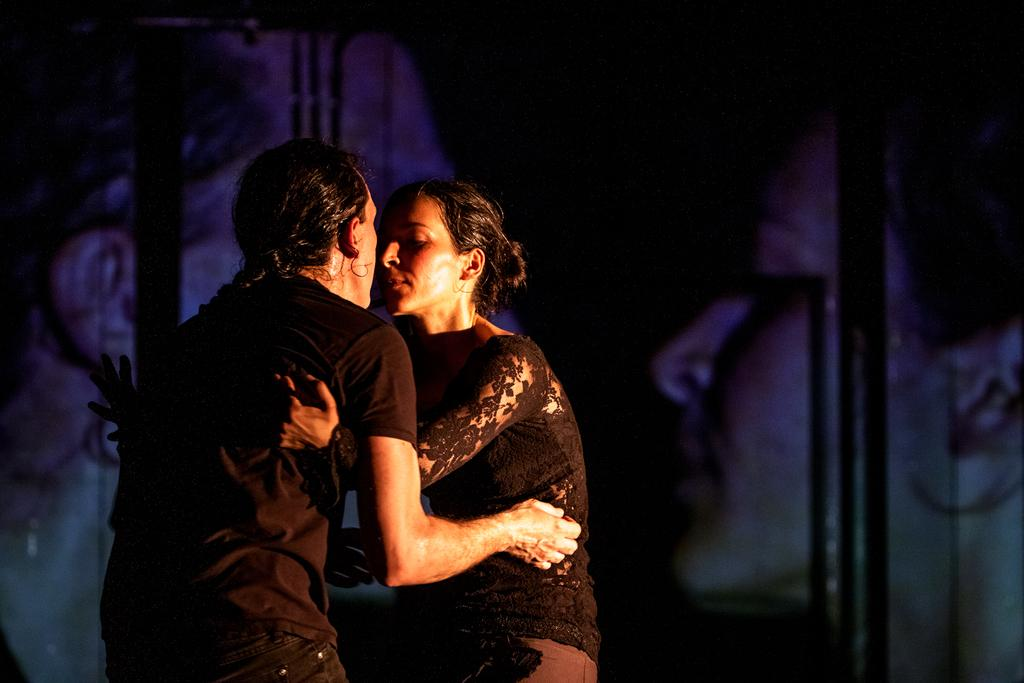How many people are in the image? There are two persons in the image. Where are the two persons located in the image? The two persons are in the middle of the image. What can be seen in the background of the image? There is a wall in the background of the image. What type of education can be seen in the image? There is no indication of education in the image; it features two persons in the middle of the image with a wall in the background. 